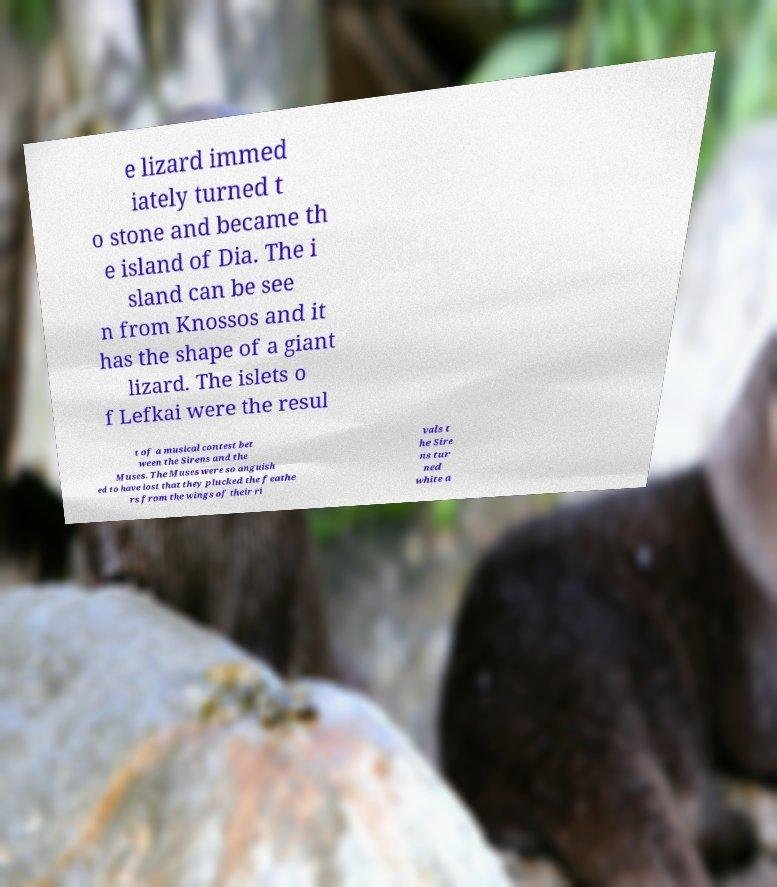Can you accurately transcribe the text from the provided image for me? e lizard immed iately turned t o stone and became th e island of Dia. The i sland can be see n from Knossos and it has the shape of a giant lizard. The islets o f Lefkai were the resul t of a musical contest bet ween the Sirens and the Muses. The Muses were so anguish ed to have lost that they plucked the feathe rs from the wings of their ri vals t he Sire ns tur ned white a 